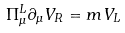Convert formula to latex. <formula><loc_0><loc_0><loc_500><loc_500>\Pi _ { \mu } ^ { L } \partial _ { \mu } V _ { R } = m V _ { L }</formula> 